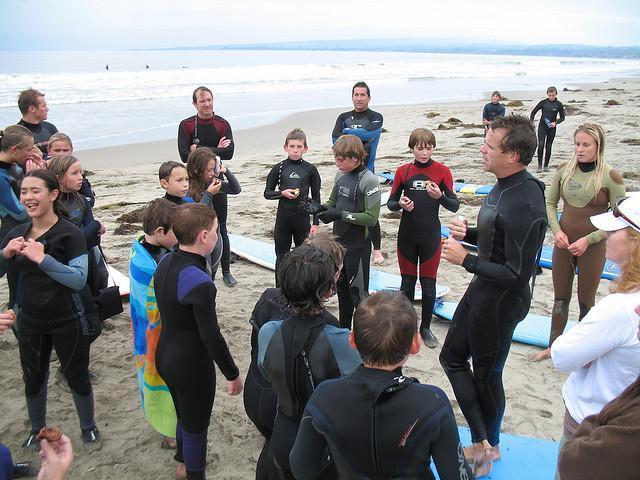How many people are wrapped in towels?
Give a very brief answer. 1. How many surfboards can you see?
Give a very brief answer. 2. How many people are in the photo?
Give a very brief answer. 11. How many ovens does this kitchen have?
Give a very brief answer. 0. 